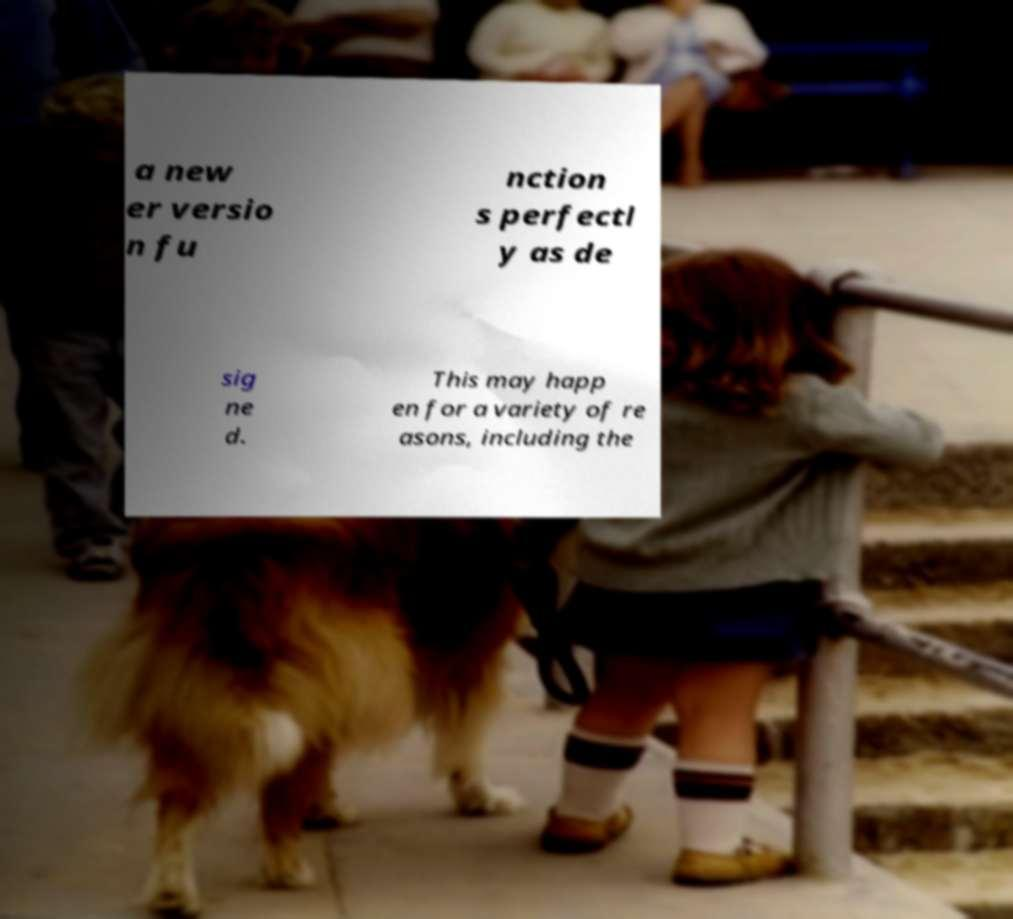For documentation purposes, I need the text within this image transcribed. Could you provide that? a new er versio n fu nction s perfectl y as de sig ne d. This may happ en for a variety of re asons, including the 